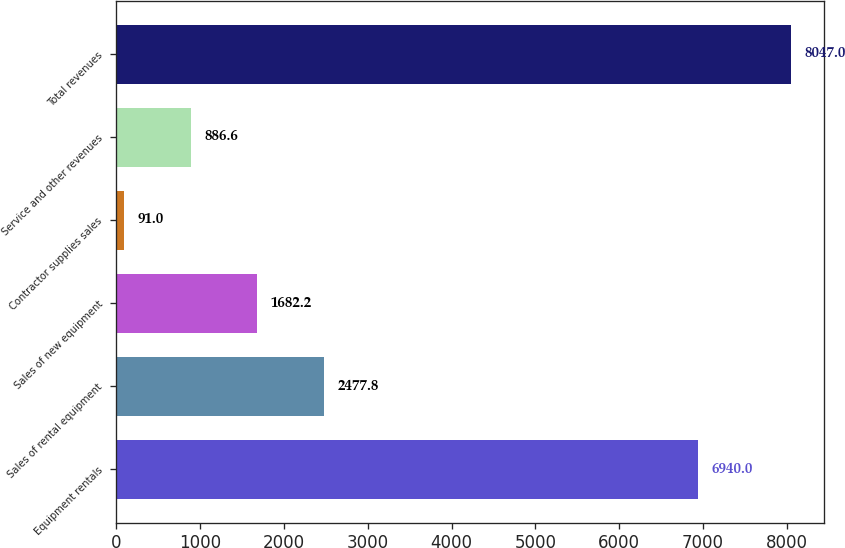Convert chart. <chart><loc_0><loc_0><loc_500><loc_500><bar_chart><fcel>Equipment rentals<fcel>Sales of rental equipment<fcel>Sales of new equipment<fcel>Contractor supplies sales<fcel>Service and other revenues<fcel>Total revenues<nl><fcel>6940<fcel>2477.8<fcel>1682.2<fcel>91<fcel>886.6<fcel>8047<nl></chart> 